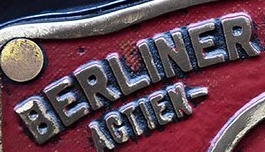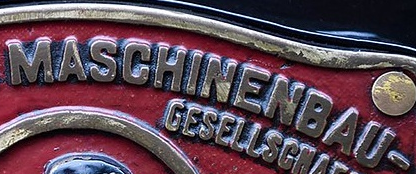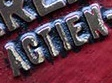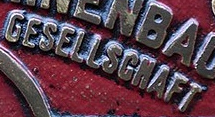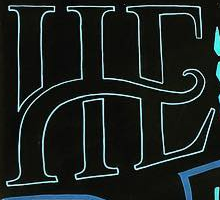Transcribe the words shown in these images in order, separated by a semicolon. BERLINER; MASCHINENBAU; AGTIEN; GESELLSGNAFT; HE 